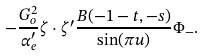Convert formula to latex. <formula><loc_0><loc_0><loc_500><loc_500>- \frac { G _ { o } ^ { 2 } } { \alpha _ { e } ^ { \prime } } \zeta \cdot \zeta ^ { \prime } \frac { B ( - 1 - t , - s ) } { \sin ( \pi u ) } \Phi _ { - } .</formula> 